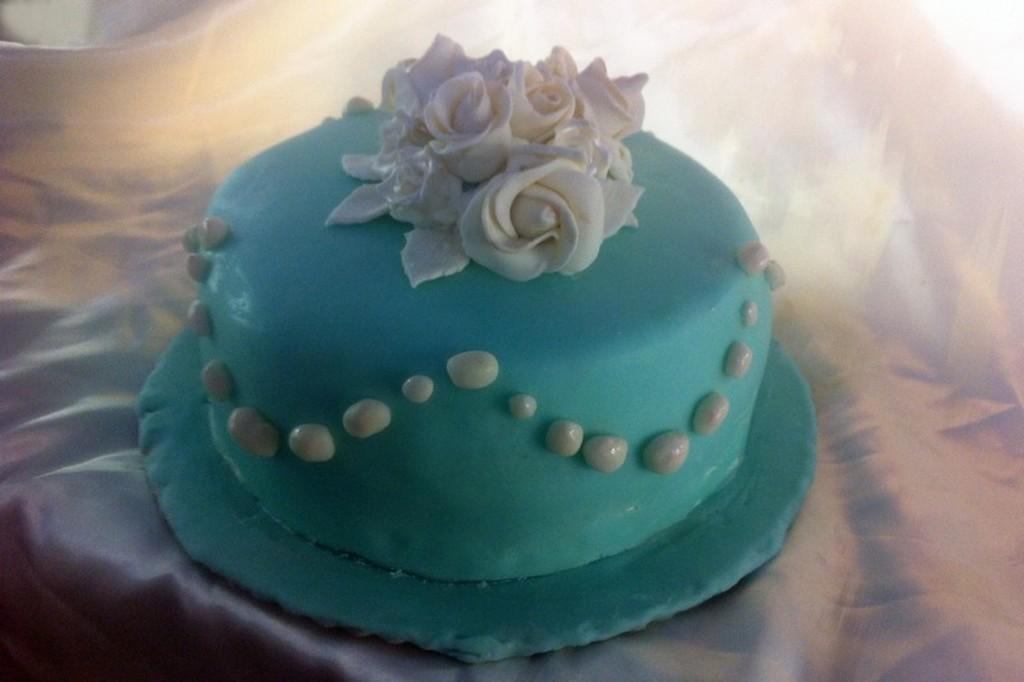Could you give a brief overview of what you see in this image? Here I can see a table which is covered with a white cloth. On the table there is a cake. 